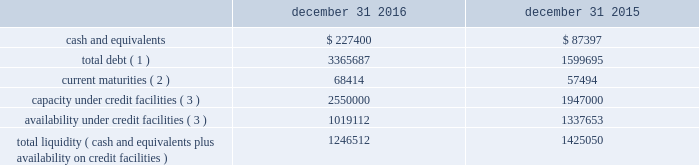Liquidity and capital resources the table summarizes liquidity data as of the dates indicated ( in thousands ) : december 31 , december 31 .
Total debt ( 1 ) 3365687 1599695 current maturities ( 2 ) 68414 57494 capacity under credit facilities ( 3 ) 2550000 1947000 availability under credit facilities ( 3 ) 1019112 1337653 total liquidity ( cash and equivalents plus availability on credit facilities ) 1246512 1425050 ( 1 ) debt amounts reflect the gross values to be repaid ( excluding debt issuance costs of $ 23.9 million and $ 15.0 million as of december 31 , 2016 and 2015 , respectively ) .
( 2 ) debt amounts reflect the gross values to be repaid ( excluding debt issuance costs of $ 2.3 million and $ 1.5 million as of december 31 , 2016 and 2015 , respectively ) .
( 3 ) includes our revolving credit facilities , our receivables securitization facility , and letters of credit .
We assess our liquidity in terms of our ability to fund our operations and provide for expansion through both internal development and acquisitions .
Our primary sources of liquidity are cash flows from operations and our credit facilities .
We utilize our cash flows from operations to fund working capital and capital expenditures , with the excess amounts going towards funding acquisitions or paying down outstanding debt .
As we have pursued acquisitions as part of our growth strategy , our cash flows from operations have not always been sufficient to cover our investing activities .
To fund our acquisitions , we have accessed various forms of debt financing , including revolving credit facilities , senior notes , and a receivables securitization facility .
As of december 31 , 2016 , we had debt outstanding and additional available sources of financing , as follows : 2022 senior secured credit facilities maturing in january 2021 , composed of term loans totaling $ 750 million ( $ 732.7 million outstanding at december 31 , 2016 ) and $ 2.45 billion in revolving credit ( $ 1.36 billion outstanding at december 31 , 2016 ) , bearing interest at variable rates ( although a portion of this debt is hedged through interest rate swap contracts ) reduced by $ 72.7 million of amounts outstanding under letters of credit 2022 senior notes totaling $ 600 million , maturing in may 2023 and bearing interest at a 4.75% ( 4.75 % ) fixed rate 2022 euro notes totaling $ 526 million ( 20ac500 million ) , maturing in april 2024 and bearing interest at a 3.875% ( 3.875 % ) fixed rate 2022 receivables securitization facility with availability up to $ 100 million ( $ 100 million outstanding as of december 31 , 2016 ) , maturing in november 2019 and bearing interest at variable commercial paper from time to time , we may undertake financing transactions to increase our available liquidity , such as our january 2016 amendment to our senior secured credit facilities , the issuance of 20ac500 million of euro notes in april 2016 , and the november 2016 amendment to our receivables securitization facility .
The rhiag acquisition was the catalyst for the april issuance of 20ac500 million of euro notes .
Given that rhiag is a long term asset , we considered alternative financing options and decided to fund a portion of this acquisition through the issuance of long term notes .
Additionally , the interest rates on rhiag's acquired debt ranged between 6.45% ( 6.45 % ) and 7.25% ( 7.25 % ) .
With the issuance of the 20ac500 million of senior notes at a rate of 3.875% ( 3.875 % ) , we were able to replace rhiag's borrowings with long term financing at favorable rates .
This refinancing also provides financial flexibility to execute our long-term growth strategy by freeing up availability under our revolver .
If we see an attractive acquisition opportunity , we have the ability to use our revolver to move quickly and have certainty of funding .
As of december 31 , 2016 , we had approximately $ 1.02 billion available under our credit facilities .
Combined with approximately $ 227.4 million of cash and equivalents at december 31 , 2016 , we had approximately $ 1.25 billion in available liquidity , a decrease of $ 178.5 million from our available liquidity as of december 31 , 2015 .
We expect to use the proceeds from the sale of pgw's glass manufacturing business to pay down borrowings under our revolving credit facilities , which would increase our available liquidity by approximately $ 310 million when the transaction closes. .
What was the change in cash and equivalents from 2015 to 2016? 
Computations: (227400 - 87397)
Answer: 140003.0. 